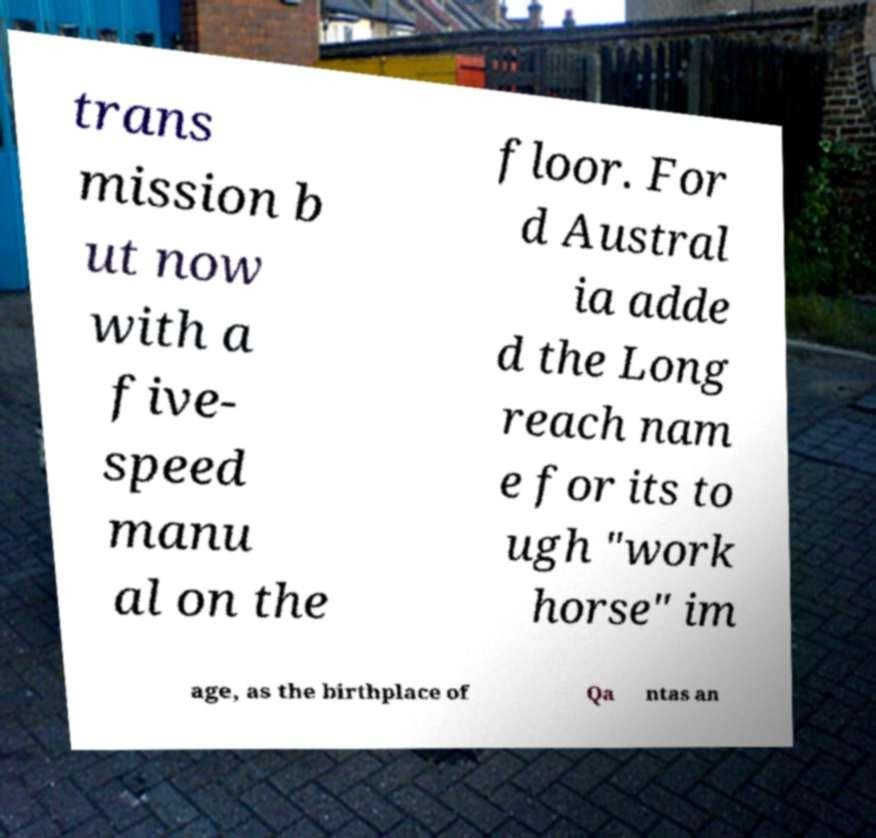Could you assist in decoding the text presented in this image and type it out clearly? trans mission b ut now with a five- speed manu al on the floor. For d Austral ia adde d the Long reach nam e for its to ugh "work horse" im age, as the birthplace of Qa ntas an 